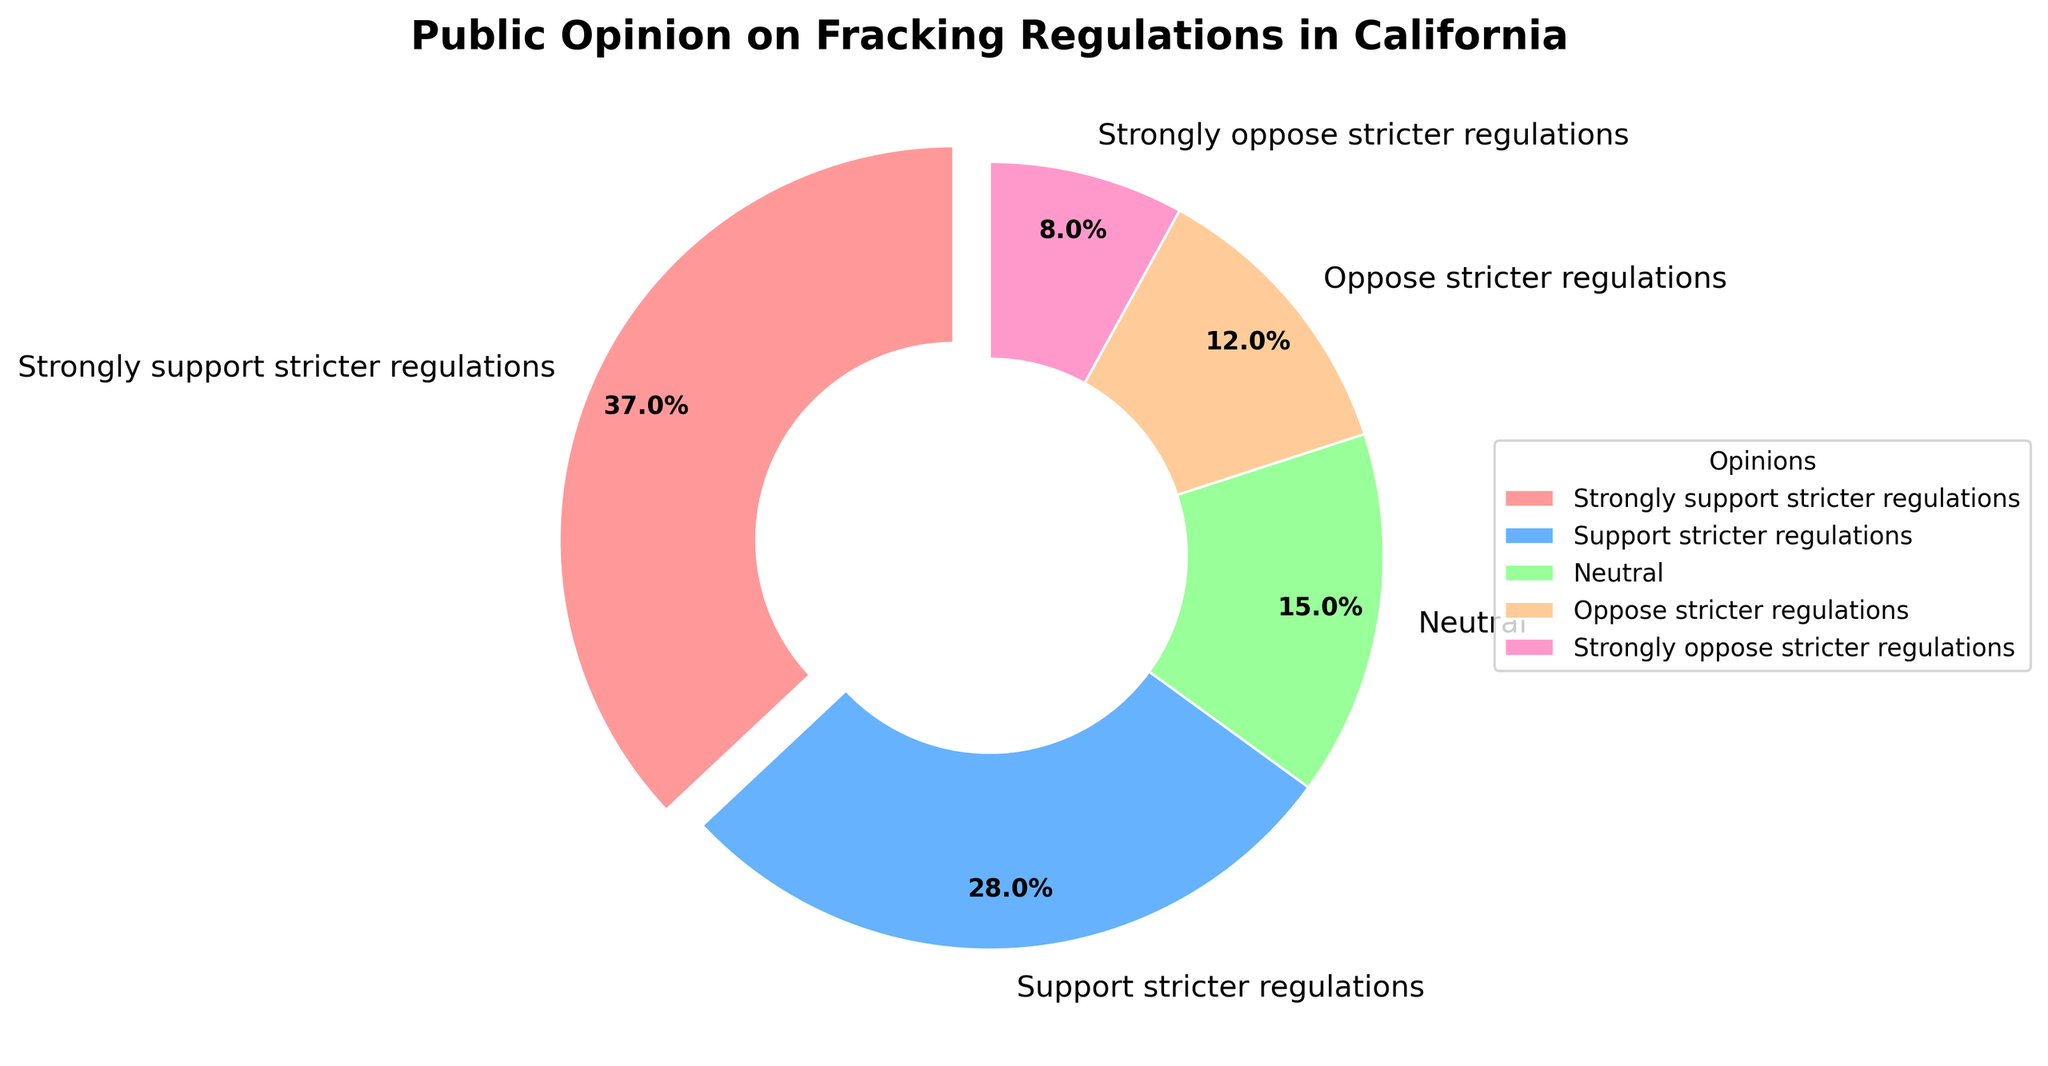Which opinion group has the largest percentage? The pie chart shows the percentages for each opinion group. The largest wedge corresponds to "Strongly support stricter regulations," highlighted in red.
Answer: Strongly support stricter regulations How many opinion groups collectively make up more than 50% of the total percentage? Summing the percentages in descending order: 37% (Strongly support stricter regulations) + 28% (Support stricter regulations) = 65%. Thus, the top two groups collectively exceed 50%.
Answer: 2 Which opinion group is represented by the blue wedge? The legend associates colors with opinion groups. The blue wedge corresponds to "Support stricter regulations."
Answer: Support stricter regulations What is the difference in percentage between those who strongly support and those who oppose stricter regulations? From the chart, subtract the percentage of "Oppose stricter regulations" (12%) from "Strongly support stricter regulations" (37%): 37% - 12% = 25%.
Answer: 25% Which group makes up the smallest percentage? The pie chart indicates the smallest wedge and its corresponding label. "Strongly oppose stricter regulations," highlighted in pink, has the smallest percentage of 8%.
Answer: Strongly oppose stricter regulations What is the combined percentage of those who are neutral or oppose stricter regulations? Add the percentages of "Neutral" (15%) and "Oppose stricter regulations" (12%): 15% + 12% = 27%.
Answer: 27% How much more popular is the support for stricter regulations (both strong and regular) than opposition (both strong and regular)? Sum the support percentages: 37% (Strongly support) + 28% (Support) = 65%. Sum the opposition percentages: 8% (Strongly oppose) + 12% (Oppose) = 20%. Calculate the difference: 65% - 20% = 45%.
Answer: 45% 